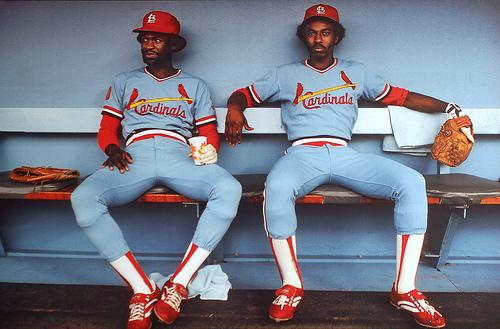What kind of sentiment or emotions does the image evoke? The image evokes a sense of camaraderie, teamwork, and relaxation among the baseball players taking a break. Identify the specific parts of the baseball players' outfits that have the team logo and name displayed. The St. Louis Cardinals club logo can be found on their jerseys and the name "Cardinals" is written on the front of their jerseys. Rate the image quality on a scale of 1 to 5, where 1 is poor quality and 5 is excellent quality. Considering the clarity of details and colors, I would rate the image quality as 4 out of 5. Count the number of red and white socks and shoes present in the image. There are five red and white socks and four red and white shoes in the image. Analyze the image and provide a brief description of the outfits and accessories of the baseball players. The baseball players are wearing blue jerseys with red letters, blue pants, red hats with white letters, red and white socks, red and white shoes, and holding baseball gloves or a cup. Elaborate on the composition and specifics of the environment and setting of the image. The environment consists of baseball players sitting on a bench with a floor underneath them. Some details include parts of the floor, white lines on the floor, and a baseball glove laying on the bench. Deduce any possible interactions or activities of the baseball players within the image. The baseball players might be discussing their game strategy, sharing experiences, resting after a tiring game, or preparing for the next inning. What is the dominant object and its interaction in the image? The dominant objects are two baseball players sitting on a bench, discussing with each other or taking a break. Examine the image and describe the footwear of the baseball players. The baseball players are wearing red and white shoes with matching red and white socks. Identify the primary color of baseball players' jerseys and the name of their team. The baseball players are wearing blue jerseys and they belong to the St. Louis Cardinals team. What does the man holding a white cup appear to be doing? Resting or taking a break Notice the cat sitting beside one of the baseball players. No, it's not mentioned in the image. What color are the shirts and pants of the men sitting on the bench in the image? Shirts are blue and pants are blue What color gloves do the baseball players use? Light brown What kind of footwear do the men in the image have? Red and white shoes Identify the text visible on the jerseys of the baseball players in the image. Cardinals Describe the appearance of the shoe worn by the baseball players in the image. Red and white shoe with prominent design Analyze the composition of the image and describe the central focus. Two baseball players in St. Louis Cardinals uniforms sitting on a bench with various objects scattered around them. Name the emotions displayed on the face of the baseball player. Neutral or focused Can you find the blue and yellow striped sock on one of the players? All the described socks are red and white, so asking the viewer to find a blue and yellow striped sock is misleading. According to the image, what are the colors of the St. Louis Cardinals club logo? Red, white, and navy blue What color is the baseball player's hat?  b) Red and white Write a brief caption that describes the main objects in the image. Baseball players in blue uniforms, red and white socks, and red and white shoes seated on bench with St. Louis Cardinals logo visible. Describe the visible portion of the floor in the image. Gray flooring with some lined portions Identify the baseball team based on the logo present in the image. St. Louis Cardinals What are the pants' color that the men in the image are wearing? Blue Find the color of the baseball shoes in the image. Red A baseball player with a yellow jersey is standing in the background. Can you identify him? None of the baseball players are described as wearing a yellow jersey, so asking the viewer to identify one is misleading. What objects is one of the players holding in his hand? White cup and baseball glove What are the men wearing in the image sitting on? A bench What are the prominent colors seen on the sock worn by the baseball players in the image? Red and white What activity are the two baseball players engaged in? Sitting down and resting 